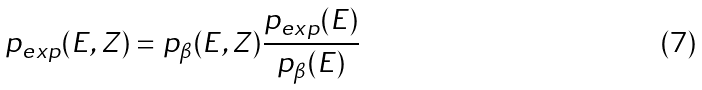Convert formula to latex. <formula><loc_0><loc_0><loc_500><loc_500>p _ { e x p } ( E , Z ) = p _ { \beta } ( E , Z ) \frac { p _ { e x p } ( E ) } { p _ { \beta } ( E ) }</formula> 